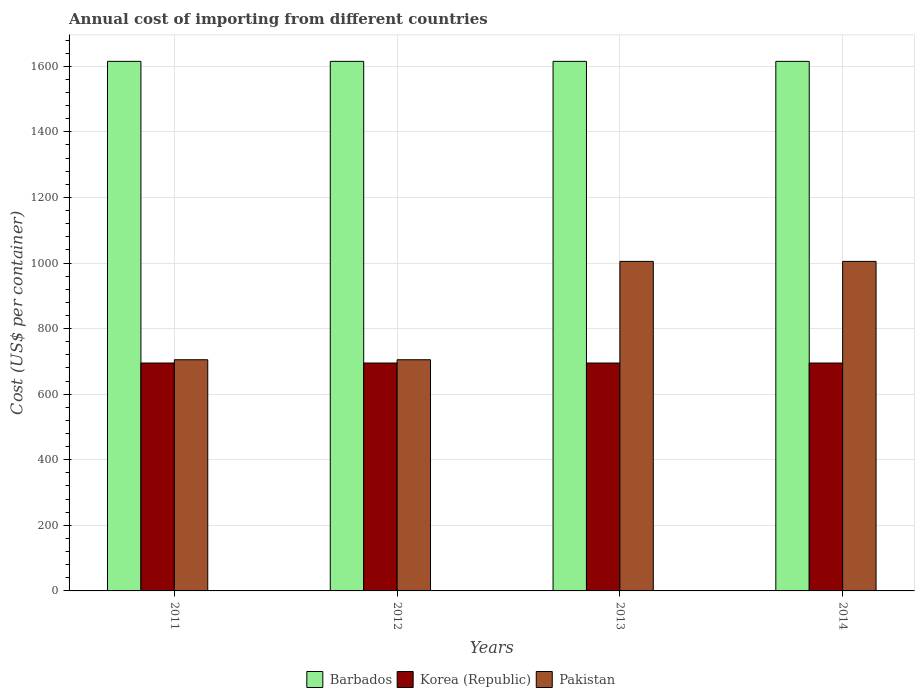How many groups of bars are there?
Provide a succinct answer. 4. Are the number of bars on each tick of the X-axis equal?
Offer a terse response. Yes. How many bars are there on the 2nd tick from the left?
Your answer should be compact. 3. In how many cases, is the number of bars for a given year not equal to the number of legend labels?
Make the answer very short. 0. What is the total annual cost of importing in Pakistan in 2013?
Provide a short and direct response. 1005. Across all years, what is the maximum total annual cost of importing in Korea (Republic)?
Provide a succinct answer. 695. Across all years, what is the minimum total annual cost of importing in Pakistan?
Provide a short and direct response. 705. What is the total total annual cost of importing in Korea (Republic) in the graph?
Offer a very short reply. 2780. What is the difference between the total annual cost of importing in Korea (Republic) in 2012 and that in 2014?
Offer a terse response. 0. What is the difference between the total annual cost of importing in Korea (Republic) in 2012 and the total annual cost of importing in Pakistan in 2013?
Give a very brief answer. -310. What is the average total annual cost of importing in Pakistan per year?
Make the answer very short. 855. In the year 2014, what is the difference between the total annual cost of importing in Korea (Republic) and total annual cost of importing in Pakistan?
Provide a short and direct response. -310. Is the total annual cost of importing in Barbados in 2013 less than that in 2014?
Your answer should be very brief. No. What is the difference between the highest and the lowest total annual cost of importing in Pakistan?
Offer a very short reply. 300. Is the sum of the total annual cost of importing in Pakistan in 2011 and 2012 greater than the maximum total annual cost of importing in Korea (Republic) across all years?
Give a very brief answer. Yes. What does the 1st bar from the left in 2013 represents?
Ensure brevity in your answer.  Barbados. What does the 1st bar from the right in 2012 represents?
Your response must be concise. Pakistan. How many bars are there?
Provide a succinct answer. 12. Are the values on the major ticks of Y-axis written in scientific E-notation?
Your answer should be very brief. No. What is the title of the graph?
Provide a short and direct response. Annual cost of importing from different countries. What is the label or title of the Y-axis?
Make the answer very short. Cost (US$ per container). What is the Cost (US$ per container) of Barbados in 2011?
Give a very brief answer. 1615. What is the Cost (US$ per container) of Korea (Republic) in 2011?
Offer a very short reply. 695. What is the Cost (US$ per container) of Pakistan in 2011?
Offer a very short reply. 705. What is the Cost (US$ per container) in Barbados in 2012?
Your response must be concise. 1615. What is the Cost (US$ per container) in Korea (Republic) in 2012?
Provide a short and direct response. 695. What is the Cost (US$ per container) in Pakistan in 2012?
Your response must be concise. 705. What is the Cost (US$ per container) of Barbados in 2013?
Provide a short and direct response. 1615. What is the Cost (US$ per container) in Korea (Republic) in 2013?
Offer a terse response. 695. What is the Cost (US$ per container) of Pakistan in 2013?
Your response must be concise. 1005. What is the Cost (US$ per container) of Barbados in 2014?
Ensure brevity in your answer.  1615. What is the Cost (US$ per container) in Korea (Republic) in 2014?
Provide a short and direct response. 695. What is the Cost (US$ per container) in Pakistan in 2014?
Provide a succinct answer. 1005. Across all years, what is the maximum Cost (US$ per container) in Barbados?
Provide a succinct answer. 1615. Across all years, what is the maximum Cost (US$ per container) in Korea (Republic)?
Offer a terse response. 695. Across all years, what is the maximum Cost (US$ per container) in Pakistan?
Make the answer very short. 1005. Across all years, what is the minimum Cost (US$ per container) in Barbados?
Keep it short and to the point. 1615. Across all years, what is the minimum Cost (US$ per container) in Korea (Republic)?
Keep it short and to the point. 695. Across all years, what is the minimum Cost (US$ per container) of Pakistan?
Your response must be concise. 705. What is the total Cost (US$ per container) in Barbados in the graph?
Keep it short and to the point. 6460. What is the total Cost (US$ per container) of Korea (Republic) in the graph?
Keep it short and to the point. 2780. What is the total Cost (US$ per container) of Pakistan in the graph?
Provide a succinct answer. 3420. What is the difference between the Cost (US$ per container) in Barbados in 2011 and that in 2012?
Your answer should be compact. 0. What is the difference between the Cost (US$ per container) in Korea (Republic) in 2011 and that in 2012?
Your answer should be very brief. 0. What is the difference between the Cost (US$ per container) in Pakistan in 2011 and that in 2012?
Keep it short and to the point. 0. What is the difference between the Cost (US$ per container) of Barbados in 2011 and that in 2013?
Give a very brief answer. 0. What is the difference between the Cost (US$ per container) of Korea (Republic) in 2011 and that in 2013?
Offer a very short reply. 0. What is the difference between the Cost (US$ per container) of Pakistan in 2011 and that in 2013?
Your answer should be very brief. -300. What is the difference between the Cost (US$ per container) of Barbados in 2011 and that in 2014?
Give a very brief answer. 0. What is the difference between the Cost (US$ per container) of Korea (Republic) in 2011 and that in 2014?
Ensure brevity in your answer.  0. What is the difference between the Cost (US$ per container) of Pakistan in 2011 and that in 2014?
Provide a short and direct response. -300. What is the difference between the Cost (US$ per container) in Barbados in 2012 and that in 2013?
Offer a terse response. 0. What is the difference between the Cost (US$ per container) in Pakistan in 2012 and that in 2013?
Give a very brief answer. -300. What is the difference between the Cost (US$ per container) of Pakistan in 2012 and that in 2014?
Offer a very short reply. -300. What is the difference between the Cost (US$ per container) in Korea (Republic) in 2013 and that in 2014?
Offer a very short reply. 0. What is the difference between the Cost (US$ per container) in Pakistan in 2013 and that in 2014?
Offer a very short reply. 0. What is the difference between the Cost (US$ per container) in Barbados in 2011 and the Cost (US$ per container) in Korea (Republic) in 2012?
Give a very brief answer. 920. What is the difference between the Cost (US$ per container) of Barbados in 2011 and the Cost (US$ per container) of Pakistan in 2012?
Ensure brevity in your answer.  910. What is the difference between the Cost (US$ per container) in Barbados in 2011 and the Cost (US$ per container) in Korea (Republic) in 2013?
Offer a terse response. 920. What is the difference between the Cost (US$ per container) of Barbados in 2011 and the Cost (US$ per container) of Pakistan in 2013?
Offer a very short reply. 610. What is the difference between the Cost (US$ per container) in Korea (Republic) in 2011 and the Cost (US$ per container) in Pakistan in 2013?
Offer a terse response. -310. What is the difference between the Cost (US$ per container) of Barbados in 2011 and the Cost (US$ per container) of Korea (Republic) in 2014?
Offer a terse response. 920. What is the difference between the Cost (US$ per container) of Barbados in 2011 and the Cost (US$ per container) of Pakistan in 2014?
Make the answer very short. 610. What is the difference between the Cost (US$ per container) in Korea (Republic) in 2011 and the Cost (US$ per container) in Pakistan in 2014?
Give a very brief answer. -310. What is the difference between the Cost (US$ per container) of Barbados in 2012 and the Cost (US$ per container) of Korea (Republic) in 2013?
Keep it short and to the point. 920. What is the difference between the Cost (US$ per container) in Barbados in 2012 and the Cost (US$ per container) in Pakistan in 2013?
Provide a short and direct response. 610. What is the difference between the Cost (US$ per container) in Korea (Republic) in 2012 and the Cost (US$ per container) in Pakistan in 2013?
Make the answer very short. -310. What is the difference between the Cost (US$ per container) in Barbados in 2012 and the Cost (US$ per container) in Korea (Republic) in 2014?
Give a very brief answer. 920. What is the difference between the Cost (US$ per container) in Barbados in 2012 and the Cost (US$ per container) in Pakistan in 2014?
Give a very brief answer. 610. What is the difference between the Cost (US$ per container) in Korea (Republic) in 2012 and the Cost (US$ per container) in Pakistan in 2014?
Make the answer very short. -310. What is the difference between the Cost (US$ per container) of Barbados in 2013 and the Cost (US$ per container) of Korea (Republic) in 2014?
Keep it short and to the point. 920. What is the difference between the Cost (US$ per container) of Barbados in 2013 and the Cost (US$ per container) of Pakistan in 2014?
Offer a terse response. 610. What is the difference between the Cost (US$ per container) in Korea (Republic) in 2013 and the Cost (US$ per container) in Pakistan in 2014?
Ensure brevity in your answer.  -310. What is the average Cost (US$ per container) of Barbados per year?
Ensure brevity in your answer.  1615. What is the average Cost (US$ per container) in Korea (Republic) per year?
Make the answer very short. 695. What is the average Cost (US$ per container) in Pakistan per year?
Give a very brief answer. 855. In the year 2011, what is the difference between the Cost (US$ per container) of Barbados and Cost (US$ per container) of Korea (Republic)?
Your answer should be very brief. 920. In the year 2011, what is the difference between the Cost (US$ per container) of Barbados and Cost (US$ per container) of Pakistan?
Your answer should be compact. 910. In the year 2011, what is the difference between the Cost (US$ per container) of Korea (Republic) and Cost (US$ per container) of Pakistan?
Your answer should be compact. -10. In the year 2012, what is the difference between the Cost (US$ per container) in Barbados and Cost (US$ per container) in Korea (Republic)?
Provide a succinct answer. 920. In the year 2012, what is the difference between the Cost (US$ per container) in Barbados and Cost (US$ per container) in Pakistan?
Make the answer very short. 910. In the year 2012, what is the difference between the Cost (US$ per container) in Korea (Republic) and Cost (US$ per container) in Pakistan?
Make the answer very short. -10. In the year 2013, what is the difference between the Cost (US$ per container) of Barbados and Cost (US$ per container) of Korea (Republic)?
Make the answer very short. 920. In the year 2013, what is the difference between the Cost (US$ per container) in Barbados and Cost (US$ per container) in Pakistan?
Your answer should be compact. 610. In the year 2013, what is the difference between the Cost (US$ per container) of Korea (Republic) and Cost (US$ per container) of Pakistan?
Give a very brief answer. -310. In the year 2014, what is the difference between the Cost (US$ per container) in Barbados and Cost (US$ per container) in Korea (Republic)?
Offer a terse response. 920. In the year 2014, what is the difference between the Cost (US$ per container) of Barbados and Cost (US$ per container) of Pakistan?
Offer a very short reply. 610. In the year 2014, what is the difference between the Cost (US$ per container) of Korea (Republic) and Cost (US$ per container) of Pakistan?
Your answer should be compact. -310. What is the ratio of the Cost (US$ per container) of Barbados in 2011 to that in 2012?
Make the answer very short. 1. What is the ratio of the Cost (US$ per container) in Pakistan in 2011 to that in 2013?
Give a very brief answer. 0.7. What is the ratio of the Cost (US$ per container) in Barbados in 2011 to that in 2014?
Provide a short and direct response. 1. What is the ratio of the Cost (US$ per container) in Korea (Republic) in 2011 to that in 2014?
Keep it short and to the point. 1. What is the ratio of the Cost (US$ per container) in Pakistan in 2011 to that in 2014?
Your response must be concise. 0.7. What is the ratio of the Cost (US$ per container) of Pakistan in 2012 to that in 2013?
Ensure brevity in your answer.  0.7. What is the ratio of the Cost (US$ per container) in Pakistan in 2012 to that in 2014?
Your answer should be very brief. 0.7. What is the difference between the highest and the second highest Cost (US$ per container) in Pakistan?
Ensure brevity in your answer.  0. What is the difference between the highest and the lowest Cost (US$ per container) of Barbados?
Your answer should be compact. 0. What is the difference between the highest and the lowest Cost (US$ per container) of Pakistan?
Offer a very short reply. 300. 